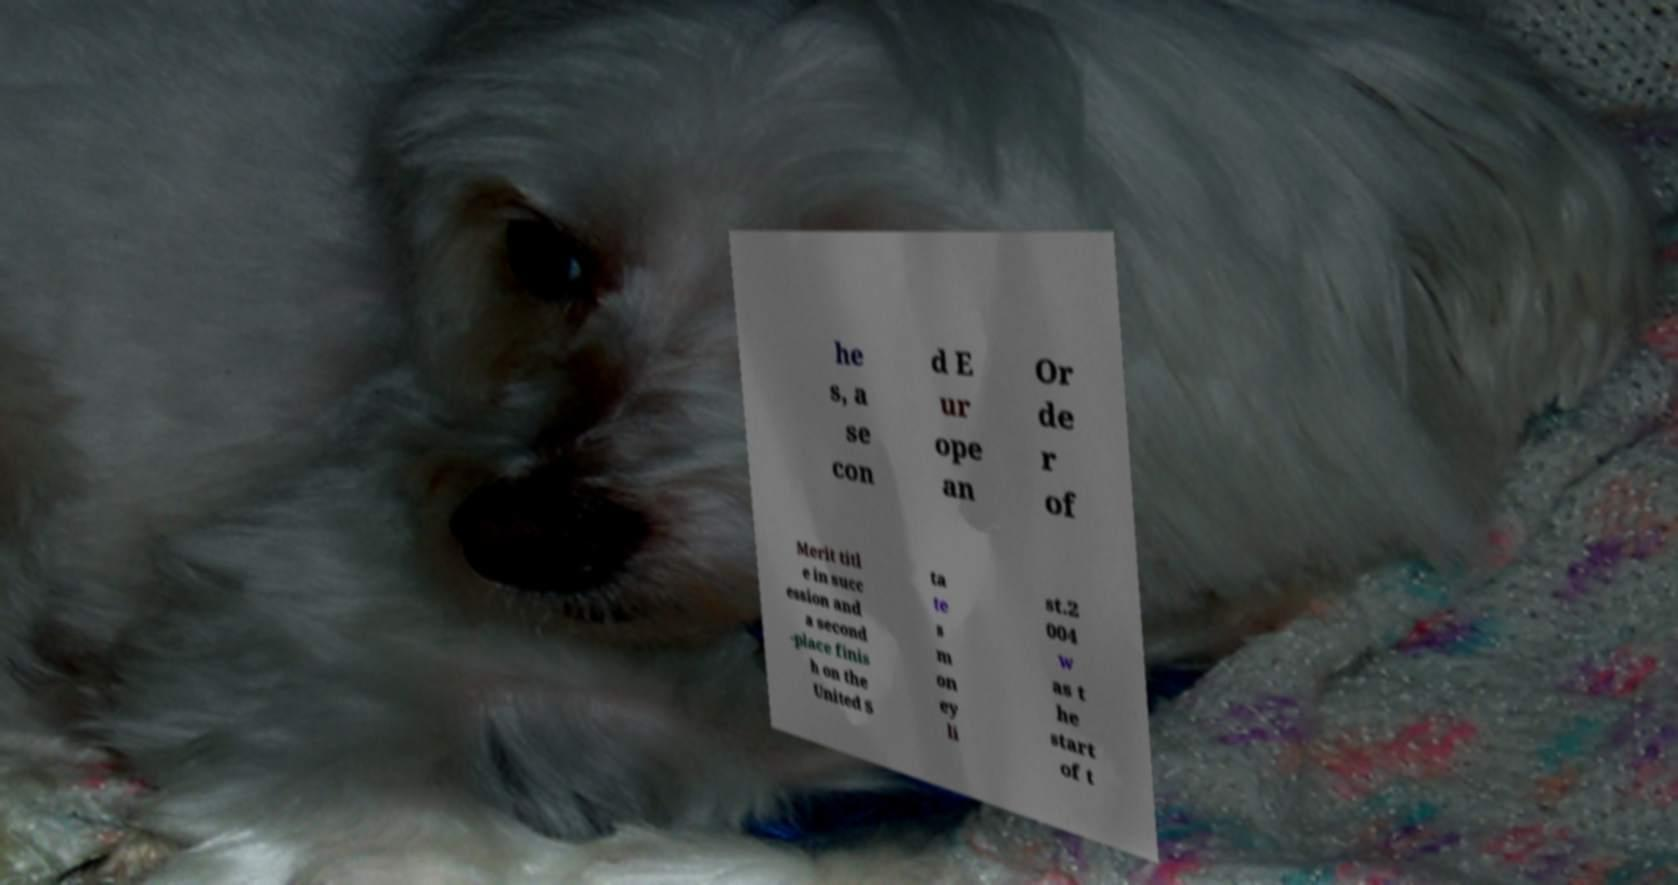What messages or text are displayed in this image? I need them in a readable, typed format. he s, a se con d E ur ope an Or de r of Merit titl e in succ ession and a second -place finis h on the United S ta te s m on ey li st.2 004 w as t he start of t 